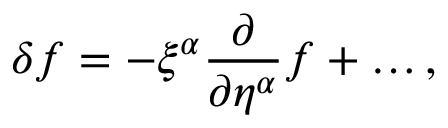Convert formula to latex. <formula><loc_0><loc_0><loc_500><loc_500>\delta f = - \xi ^ { \alpha } \frac { \partial } { \partial \eta ^ { \alpha } } f + \dots ,</formula> 